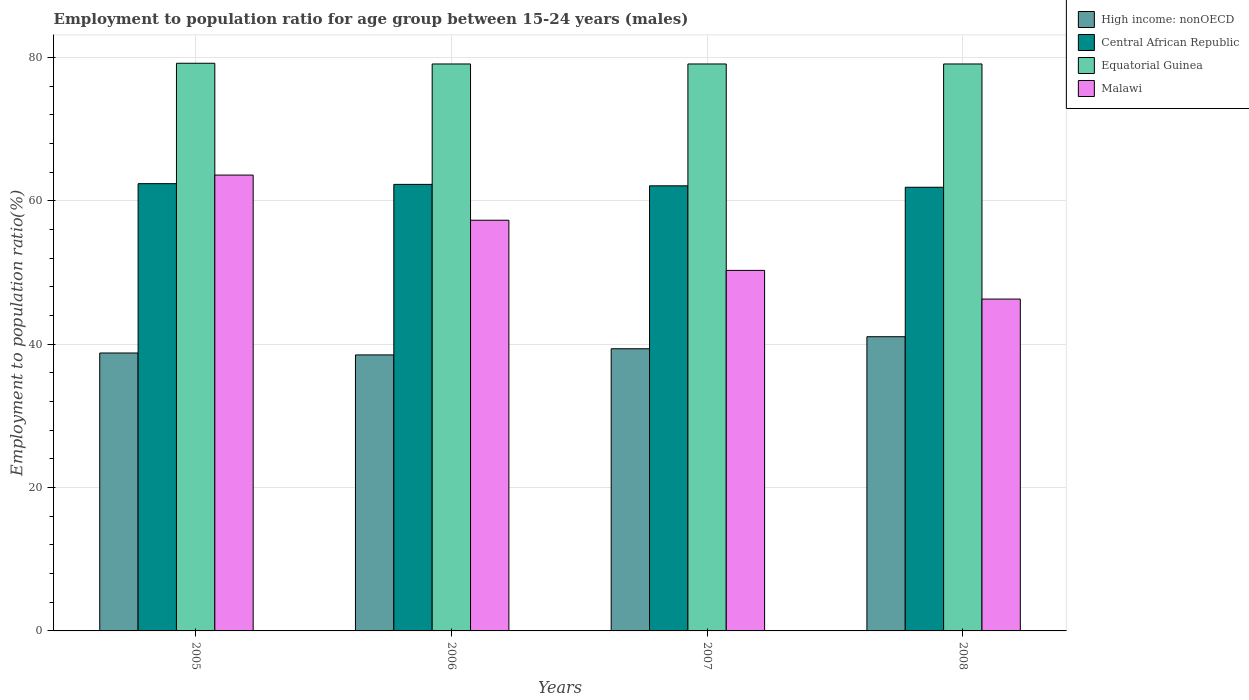How many groups of bars are there?
Provide a short and direct response. 4. Are the number of bars per tick equal to the number of legend labels?
Ensure brevity in your answer.  Yes. How many bars are there on the 2nd tick from the left?
Offer a very short reply. 4. What is the employment to population ratio in High income: nonOECD in 2008?
Offer a very short reply. 41.05. Across all years, what is the maximum employment to population ratio in Equatorial Guinea?
Make the answer very short. 79.2. Across all years, what is the minimum employment to population ratio in Central African Republic?
Offer a very short reply. 61.9. In which year was the employment to population ratio in High income: nonOECD maximum?
Your answer should be very brief. 2008. What is the total employment to population ratio in Central African Republic in the graph?
Your answer should be very brief. 248.7. What is the difference between the employment to population ratio in High income: nonOECD in 2006 and that in 2008?
Offer a terse response. -2.54. What is the difference between the employment to population ratio in High income: nonOECD in 2008 and the employment to population ratio in Malawi in 2007?
Your response must be concise. -9.25. What is the average employment to population ratio in Central African Republic per year?
Keep it short and to the point. 62.18. In the year 2006, what is the difference between the employment to population ratio in Central African Republic and employment to population ratio in Equatorial Guinea?
Provide a short and direct response. -16.8. In how many years, is the employment to population ratio in High income: nonOECD greater than 36 %?
Provide a short and direct response. 4. What is the ratio of the employment to population ratio in High income: nonOECD in 2005 to that in 2008?
Give a very brief answer. 0.94. Is the employment to population ratio in Equatorial Guinea in 2006 less than that in 2008?
Provide a succinct answer. No. What is the difference between the highest and the second highest employment to population ratio in Malawi?
Give a very brief answer. 6.3. What is the difference between the highest and the lowest employment to population ratio in Central African Republic?
Offer a very short reply. 0.5. Is the sum of the employment to population ratio in High income: nonOECD in 2007 and 2008 greater than the maximum employment to population ratio in Central African Republic across all years?
Your answer should be very brief. Yes. Is it the case that in every year, the sum of the employment to population ratio in Central African Republic and employment to population ratio in High income: nonOECD is greater than the sum of employment to population ratio in Equatorial Guinea and employment to population ratio in Malawi?
Your response must be concise. No. What does the 2nd bar from the left in 2006 represents?
Provide a succinct answer. Central African Republic. What does the 2nd bar from the right in 2006 represents?
Offer a terse response. Equatorial Guinea. Is it the case that in every year, the sum of the employment to population ratio in Equatorial Guinea and employment to population ratio in Malawi is greater than the employment to population ratio in High income: nonOECD?
Your answer should be very brief. Yes. How many bars are there?
Ensure brevity in your answer.  16. What is the difference between two consecutive major ticks on the Y-axis?
Offer a very short reply. 20. Are the values on the major ticks of Y-axis written in scientific E-notation?
Ensure brevity in your answer.  No. Does the graph contain any zero values?
Provide a short and direct response. No. Where does the legend appear in the graph?
Provide a succinct answer. Top right. How many legend labels are there?
Offer a very short reply. 4. How are the legend labels stacked?
Your answer should be very brief. Vertical. What is the title of the graph?
Keep it short and to the point. Employment to population ratio for age group between 15-24 years (males). Does "Jordan" appear as one of the legend labels in the graph?
Provide a succinct answer. No. What is the Employment to population ratio(%) of High income: nonOECD in 2005?
Offer a very short reply. 38.78. What is the Employment to population ratio(%) in Central African Republic in 2005?
Provide a short and direct response. 62.4. What is the Employment to population ratio(%) in Equatorial Guinea in 2005?
Give a very brief answer. 79.2. What is the Employment to population ratio(%) in Malawi in 2005?
Provide a short and direct response. 63.6. What is the Employment to population ratio(%) of High income: nonOECD in 2006?
Offer a very short reply. 38.51. What is the Employment to population ratio(%) in Central African Republic in 2006?
Keep it short and to the point. 62.3. What is the Employment to population ratio(%) of Equatorial Guinea in 2006?
Your response must be concise. 79.1. What is the Employment to population ratio(%) in Malawi in 2006?
Keep it short and to the point. 57.3. What is the Employment to population ratio(%) of High income: nonOECD in 2007?
Give a very brief answer. 39.37. What is the Employment to population ratio(%) of Central African Republic in 2007?
Your response must be concise. 62.1. What is the Employment to population ratio(%) of Equatorial Guinea in 2007?
Ensure brevity in your answer.  79.1. What is the Employment to population ratio(%) of Malawi in 2007?
Provide a succinct answer. 50.3. What is the Employment to population ratio(%) of High income: nonOECD in 2008?
Ensure brevity in your answer.  41.05. What is the Employment to population ratio(%) of Central African Republic in 2008?
Keep it short and to the point. 61.9. What is the Employment to population ratio(%) of Equatorial Guinea in 2008?
Provide a succinct answer. 79.1. What is the Employment to population ratio(%) in Malawi in 2008?
Give a very brief answer. 46.3. Across all years, what is the maximum Employment to population ratio(%) in High income: nonOECD?
Your answer should be compact. 41.05. Across all years, what is the maximum Employment to population ratio(%) of Central African Republic?
Make the answer very short. 62.4. Across all years, what is the maximum Employment to population ratio(%) of Equatorial Guinea?
Provide a short and direct response. 79.2. Across all years, what is the maximum Employment to population ratio(%) of Malawi?
Provide a short and direct response. 63.6. Across all years, what is the minimum Employment to population ratio(%) of High income: nonOECD?
Make the answer very short. 38.51. Across all years, what is the minimum Employment to population ratio(%) of Central African Republic?
Ensure brevity in your answer.  61.9. Across all years, what is the minimum Employment to population ratio(%) of Equatorial Guinea?
Offer a terse response. 79.1. Across all years, what is the minimum Employment to population ratio(%) of Malawi?
Your answer should be very brief. 46.3. What is the total Employment to population ratio(%) in High income: nonOECD in the graph?
Provide a succinct answer. 157.7. What is the total Employment to population ratio(%) in Central African Republic in the graph?
Offer a very short reply. 248.7. What is the total Employment to population ratio(%) of Equatorial Guinea in the graph?
Offer a terse response. 316.5. What is the total Employment to population ratio(%) of Malawi in the graph?
Provide a succinct answer. 217.5. What is the difference between the Employment to population ratio(%) of High income: nonOECD in 2005 and that in 2006?
Keep it short and to the point. 0.27. What is the difference between the Employment to population ratio(%) of Central African Republic in 2005 and that in 2006?
Your answer should be compact. 0.1. What is the difference between the Employment to population ratio(%) in Malawi in 2005 and that in 2006?
Your response must be concise. 6.3. What is the difference between the Employment to population ratio(%) of High income: nonOECD in 2005 and that in 2007?
Your answer should be very brief. -0.59. What is the difference between the Employment to population ratio(%) of Central African Republic in 2005 and that in 2007?
Your answer should be compact. 0.3. What is the difference between the Employment to population ratio(%) of Malawi in 2005 and that in 2007?
Give a very brief answer. 13.3. What is the difference between the Employment to population ratio(%) of High income: nonOECD in 2005 and that in 2008?
Keep it short and to the point. -2.27. What is the difference between the Employment to population ratio(%) in Central African Republic in 2005 and that in 2008?
Offer a very short reply. 0.5. What is the difference between the Employment to population ratio(%) in Equatorial Guinea in 2005 and that in 2008?
Make the answer very short. 0.1. What is the difference between the Employment to population ratio(%) in Malawi in 2005 and that in 2008?
Ensure brevity in your answer.  17.3. What is the difference between the Employment to population ratio(%) of High income: nonOECD in 2006 and that in 2007?
Offer a terse response. -0.86. What is the difference between the Employment to population ratio(%) of Central African Republic in 2006 and that in 2007?
Your response must be concise. 0.2. What is the difference between the Employment to population ratio(%) of High income: nonOECD in 2006 and that in 2008?
Ensure brevity in your answer.  -2.54. What is the difference between the Employment to population ratio(%) in Central African Republic in 2006 and that in 2008?
Make the answer very short. 0.4. What is the difference between the Employment to population ratio(%) in High income: nonOECD in 2007 and that in 2008?
Offer a terse response. -1.68. What is the difference between the Employment to population ratio(%) of Central African Republic in 2007 and that in 2008?
Provide a succinct answer. 0.2. What is the difference between the Employment to population ratio(%) of High income: nonOECD in 2005 and the Employment to population ratio(%) of Central African Republic in 2006?
Your answer should be very brief. -23.52. What is the difference between the Employment to population ratio(%) in High income: nonOECD in 2005 and the Employment to population ratio(%) in Equatorial Guinea in 2006?
Keep it short and to the point. -40.32. What is the difference between the Employment to population ratio(%) of High income: nonOECD in 2005 and the Employment to population ratio(%) of Malawi in 2006?
Ensure brevity in your answer.  -18.52. What is the difference between the Employment to population ratio(%) of Central African Republic in 2005 and the Employment to population ratio(%) of Equatorial Guinea in 2006?
Your response must be concise. -16.7. What is the difference between the Employment to population ratio(%) in Equatorial Guinea in 2005 and the Employment to population ratio(%) in Malawi in 2006?
Keep it short and to the point. 21.9. What is the difference between the Employment to population ratio(%) of High income: nonOECD in 2005 and the Employment to population ratio(%) of Central African Republic in 2007?
Give a very brief answer. -23.32. What is the difference between the Employment to population ratio(%) in High income: nonOECD in 2005 and the Employment to population ratio(%) in Equatorial Guinea in 2007?
Ensure brevity in your answer.  -40.32. What is the difference between the Employment to population ratio(%) of High income: nonOECD in 2005 and the Employment to population ratio(%) of Malawi in 2007?
Ensure brevity in your answer.  -11.52. What is the difference between the Employment to population ratio(%) in Central African Republic in 2005 and the Employment to population ratio(%) in Equatorial Guinea in 2007?
Your answer should be very brief. -16.7. What is the difference between the Employment to population ratio(%) of Equatorial Guinea in 2005 and the Employment to population ratio(%) of Malawi in 2007?
Offer a terse response. 28.9. What is the difference between the Employment to population ratio(%) in High income: nonOECD in 2005 and the Employment to population ratio(%) in Central African Republic in 2008?
Keep it short and to the point. -23.12. What is the difference between the Employment to population ratio(%) of High income: nonOECD in 2005 and the Employment to population ratio(%) of Equatorial Guinea in 2008?
Give a very brief answer. -40.32. What is the difference between the Employment to population ratio(%) in High income: nonOECD in 2005 and the Employment to population ratio(%) in Malawi in 2008?
Provide a succinct answer. -7.52. What is the difference between the Employment to population ratio(%) of Central African Republic in 2005 and the Employment to population ratio(%) of Equatorial Guinea in 2008?
Give a very brief answer. -16.7. What is the difference between the Employment to population ratio(%) in Equatorial Guinea in 2005 and the Employment to population ratio(%) in Malawi in 2008?
Give a very brief answer. 32.9. What is the difference between the Employment to population ratio(%) of High income: nonOECD in 2006 and the Employment to population ratio(%) of Central African Republic in 2007?
Give a very brief answer. -23.59. What is the difference between the Employment to population ratio(%) of High income: nonOECD in 2006 and the Employment to population ratio(%) of Equatorial Guinea in 2007?
Your response must be concise. -40.59. What is the difference between the Employment to population ratio(%) in High income: nonOECD in 2006 and the Employment to population ratio(%) in Malawi in 2007?
Provide a short and direct response. -11.79. What is the difference between the Employment to population ratio(%) of Central African Republic in 2006 and the Employment to population ratio(%) of Equatorial Guinea in 2007?
Offer a very short reply. -16.8. What is the difference between the Employment to population ratio(%) in Equatorial Guinea in 2006 and the Employment to population ratio(%) in Malawi in 2007?
Provide a succinct answer. 28.8. What is the difference between the Employment to population ratio(%) in High income: nonOECD in 2006 and the Employment to population ratio(%) in Central African Republic in 2008?
Your answer should be very brief. -23.39. What is the difference between the Employment to population ratio(%) of High income: nonOECD in 2006 and the Employment to population ratio(%) of Equatorial Guinea in 2008?
Ensure brevity in your answer.  -40.59. What is the difference between the Employment to population ratio(%) in High income: nonOECD in 2006 and the Employment to population ratio(%) in Malawi in 2008?
Your answer should be very brief. -7.79. What is the difference between the Employment to population ratio(%) of Central African Republic in 2006 and the Employment to population ratio(%) of Equatorial Guinea in 2008?
Your answer should be compact. -16.8. What is the difference between the Employment to population ratio(%) in Central African Republic in 2006 and the Employment to population ratio(%) in Malawi in 2008?
Offer a very short reply. 16. What is the difference between the Employment to population ratio(%) of Equatorial Guinea in 2006 and the Employment to population ratio(%) of Malawi in 2008?
Provide a succinct answer. 32.8. What is the difference between the Employment to population ratio(%) of High income: nonOECD in 2007 and the Employment to population ratio(%) of Central African Republic in 2008?
Provide a succinct answer. -22.53. What is the difference between the Employment to population ratio(%) of High income: nonOECD in 2007 and the Employment to population ratio(%) of Equatorial Guinea in 2008?
Make the answer very short. -39.73. What is the difference between the Employment to population ratio(%) in High income: nonOECD in 2007 and the Employment to population ratio(%) in Malawi in 2008?
Provide a short and direct response. -6.93. What is the difference between the Employment to population ratio(%) in Equatorial Guinea in 2007 and the Employment to population ratio(%) in Malawi in 2008?
Your response must be concise. 32.8. What is the average Employment to population ratio(%) of High income: nonOECD per year?
Provide a short and direct response. 39.42. What is the average Employment to population ratio(%) of Central African Republic per year?
Your answer should be very brief. 62.17. What is the average Employment to population ratio(%) in Equatorial Guinea per year?
Ensure brevity in your answer.  79.12. What is the average Employment to population ratio(%) in Malawi per year?
Ensure brevity in your answer.  54.38. In the year 2005, what is the difference between the Employment to population ratio(%) in High income: nonOECD and Employment to population ratio(%) in Central African Republic?
Make the answer very short. -23.62. In the year 2005, what is the difference between the Employment to population ratio(%) of High income: nonOECD and Employment to population ratio(%) of Equatorial Guinea?
Keep it short and to the point. -40.42. In the year 2005, what is the difference between the Employment to population ratio(%) in High income: nonOECD and Employment to population ratio(%) in Malawi?
Ensure brevity in your answer.  -24.82. In the year 2005, what is the difference between the Employment to population ratio(%) of Central African Republic and Employment to population ratio(%) of Equatorial Guinea?
Your response must be concise. -16.8. In the year 2005, what is the difference between the Employment to population ratio(%) in Central African Republic and Employment to population ratio(%) in Malawi?
Offer a very short reply. -1.2. In the year 2006, what is the difference between the Employment to population ratio(%) in High income: nonOECD and Employment to population ratio(%) in Central African Republic?
Keep it short and to the point. -23.79. In the year 2006, what is the difference between the Employment to population ratio(%) of High income: nonOECD and Employment to population ratio(%) of Equatorial Guinea?
Offer a very short reply. -40.59. In the year 2006, what is the difference between the Employment to population ratio(%) in High income: nonOECD and Employment to population ratio(%) in Malawi?
Provide a short and direct response. -18.79. In the year 2006, what is the difference between the Employment to population ratio(%) in Central African Republic and Employment to population ratio(%) in Equatorial Guinea?
Your answer should be very brief. -16.8. In the year 2006, what is the difference between the Employment to population ratio(%) in Equatorial Guinea and Employment to population ratio(%) in Malawi?
Offer a very short reply. 21.8. In the year 2007, what is the difference between the Employment to population ratio(%) in High income: nonOECD and Employment to population ratio(%) in Central African Republic?
Provide a succinct answer. -22.73. In the year 2007, what is the difference between the Employment to population ratio(%) in High income: nonOECD and Employment to population ratio(%) in Equatorial Guinea?
Keep it short and to the point. -39.73. In the year 2007, what is the difference between the Employment to population ratio(%) in High income: nonOECD and Employment to population ratio(%) in Malawi?
Offer a very short reply. -10.93. In the year 2007, what is the difference between the Employment to population ratio(%) in Central African Republic and Employment to population ratio(%) in Equatorial Guinea?
Provide a short and direct response. -17. In the year 2007, what is the difference between the Employment to population ratio(%) in Equatorial Guinea and Employment to population ratio(%) in Malawi?
Give a very brief answer. 28.8. In the year 2008, what is the difference between the Employment to population ratio(%) in High income: nonOECD and Employment to population ratio(%) in Central African Republic?
Offer a terse response. -20.85. In the year 2008, what is the difference between the Employment to population ratio(%) in High income: nonOECD and Employment to population ratio(%) in Equatorial Guinea?
Provide a short and direct response. -38.05. In the year 2008, what is the difference between the Employment to population ratio(%) of High income: nonOECD and Employment to population ratio(%) of Malawi?
Your response must be concise. -5.25. In the year 2008, what is the difference between the Employment to population ratio(%) in Central African Republic and Employment to population ratio(%) in Equatorial Guinea?
Ensure brevity in your answer.  -17.2. In the year 2008, what is the difference between the Employment to population ratio(%) of Central African Republic and Employment to population ratio(%) of Malawi?
Provide a succinct answer. 15.6. In the year 2008, what is the difference between the Employment to population ratio(%) in Equatorial Guinea and Employment to population ratio(%) in Malawi?
Your answer should be very brief. 32.8. What is the ratio of the Employment to population ratio(%) in Central African Republic in 2005 to that in 2006?
Keep it short and to the point. 1. What is the ratio of the Employment to population ratio(%) in Malawi in 2005 to that in 2006?
Make the answer very short. 1.11. What is the ratio of the Employment to population ratio(%) in Central African Republic in 2005 to that in 2007?
Your answer should be compact. 1. What is the ratio of the Employment to population ratio(%) of Equatorial Guinea in 2005 to that in 2007?
Make the answer very short. 1. What is the ratio of the Employment to population ratio(%) in Malawi in 2005 to that in 2007?
Keep it short and to the point. 1.26. What is the ratio of the Employment to population ratio(%) in High income: nonOECD in 2005 to that in 2008?
Make the answer very short. 0.94. What is the ratio of the Employment to population ratio(%) in Central African Republic in 2005 to that in 2008?
Ensure brevity in your answer.  1.01. What is the ratio of the Employment to population ratio(%) of Malawi in 2005 to that in 2008?
Provide a short and direct response. 1.37. What is the ratio of the Employment to population ratio(%) in High income: nonOECD in 2006 to that in 2007?
Keep it short and to the point. 0.98. What is the ratio of the Employment to population ratio(%) of Equatorial Guinea in 2006 to that in 2007?
Provide a short and direct response. 1. What is the ratio of the Employment to population ratio(%) of Malawi in 2006 to that in 2007?
Your answer should be compact. 1.14. What is the ratio of the Employment to population ratio(%) of High income: nonOECD in 2006 to that in 2008?
Make the answer very short. 0.94. What is the ratio of the Employment to population ratio(%) of Equatorial Guinea in 2006 to that in 2008?
Offer a very short reply. 1. What is the ratio of the Employment to population ratio(%) of Malawi in 2006 to that in 2008?
Offer a terse response. 1.24. What is the ratio of the Employment to population ratio(%) of High income: nonOECD in 2007 to that in 2008?
Your response must be concise. 0.96. What is the ratio of the Employment to population ratio(%) in Central African Republic in 2007 to that in 2008?
Give a very brief answer. 1. What is the ratio of the Employment to population ratio(%) in Malawi in 2007 to that in 2008?
Give a very brief answer. 1.09. What is the difference between the highest and the second highest Employment to population ratio(%) in High income: nonOECD?
Make the answer very short. 1.68. What is the difference between the highest and the second highest Employment to population ratio(%) of Equatorial Guinea?
Keep it short and to the point. 0.1. What is the difference between the highest and the lowest Employment to population ratio(%) of High income: nonOECD?
Make the answer very short. 2.54. What is the difference between the highest and the lowest Employment to population ratio(%) in Equatorial Guinea?
Offer a terse response. 0.1. 